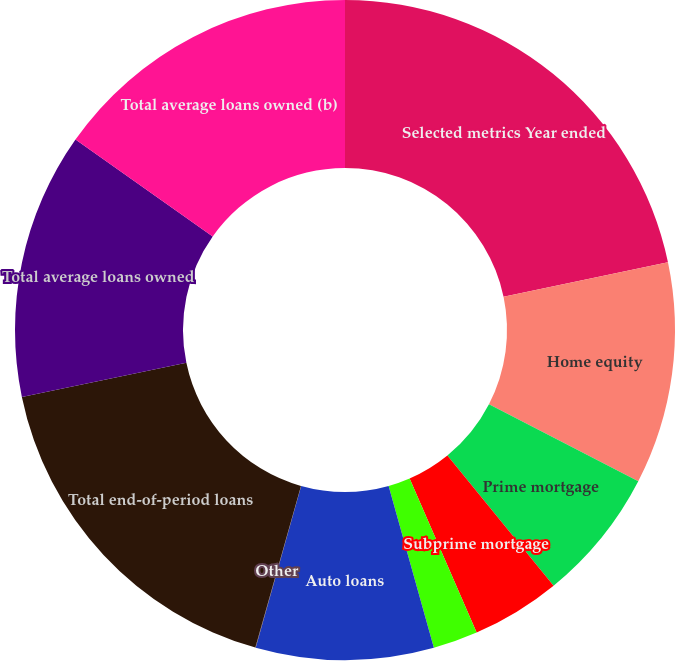Convert chart to OTSL. <chart><loc_0><loc_0><loc_500><loc_500><pie_chart><fcel>Selected metrics Year ended<fcel>Home equity<fcel>Prime mortgage<fcel>Subprime mortgage<fcel>Student loans<fcel>Auto loans<fcel>Other<fcel>Total end-of-period loans<fcel>Total average loans owned<fcel>Total average loans owned (b)<nl><fcel>21.71%<fcel>10.87%<fcel>6.53%<fcel>4.36%<fcel>2.19%<fcel>8.7%<fcel>0.02%<fcel>17.37%<fcel>13.04%<fcel>15.21%<nl></chart> 